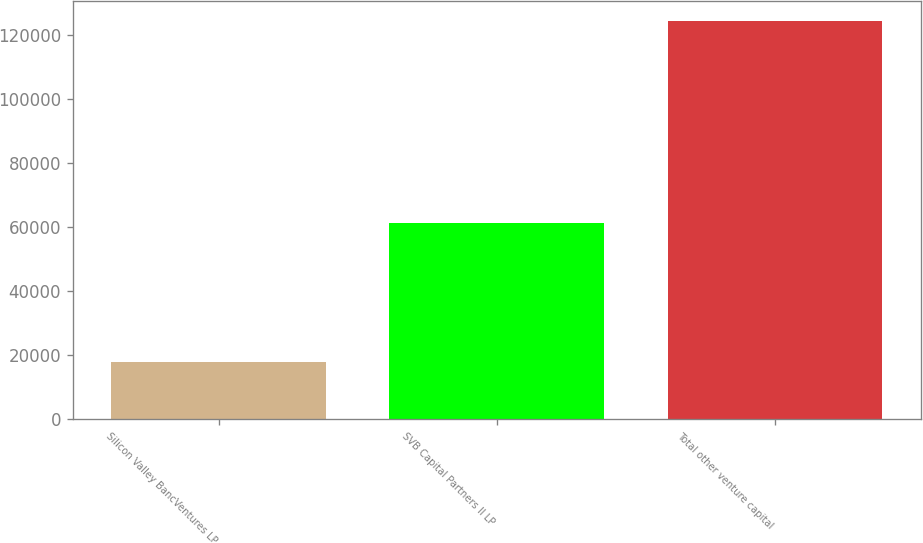<chart> <loc_0><loc_0><loc_500><loc_500><bar_chart><fcel>Silicon Valley BancVentures LP<fcel>SVB Capital Partners II LP<fcel>Total other venture capital<nl><fcel>17878<fcel>61099<fcel>124121<nl></chart> 